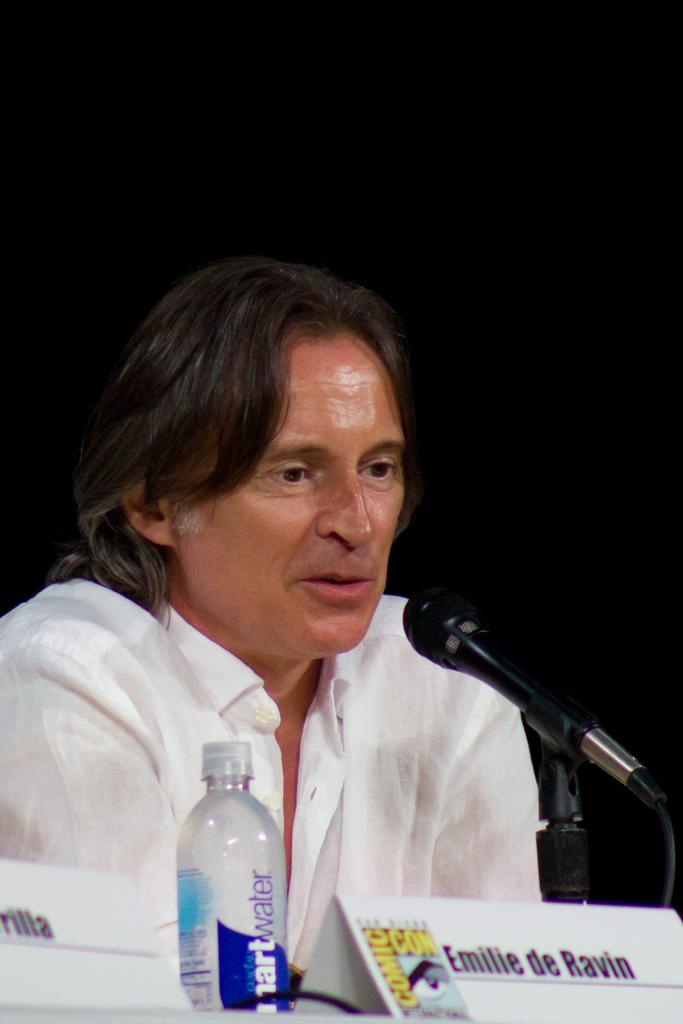What is the person in the image doing? The person is talking in front of a microphone. What is the person wearing in the image? The person is wearing a white shirt. What objects are visible in the image besides the person? There are name boards and a bottle visible in the image. How would you describe the lighting in the image? The background of the image is dark. What type of eggnog is being served at the news conference in the image? There is no eggnog or news conference present in the image; it features a person talking in front of a microphone with a dark background. 